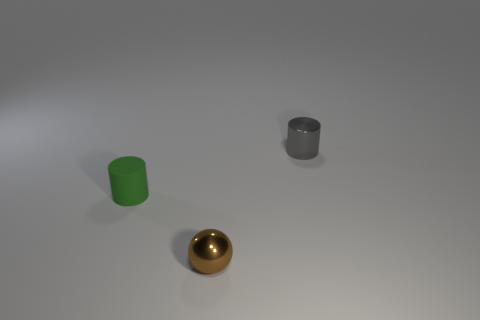Add 2 small purple metallic objects. How many objects exist? 5 Subtract all spheres. How many objects are left? 2 Subtract 1 brown balls. How many objects are left? 2 Subtract all tiny brown spheres. Subtract all blue matte cubes. How many objects are left? 2 Add 3 small metal things. How many small metal things are left? 5 Add 1 blue rubber cylinders. How many blue rubber cylinders exist? 1 